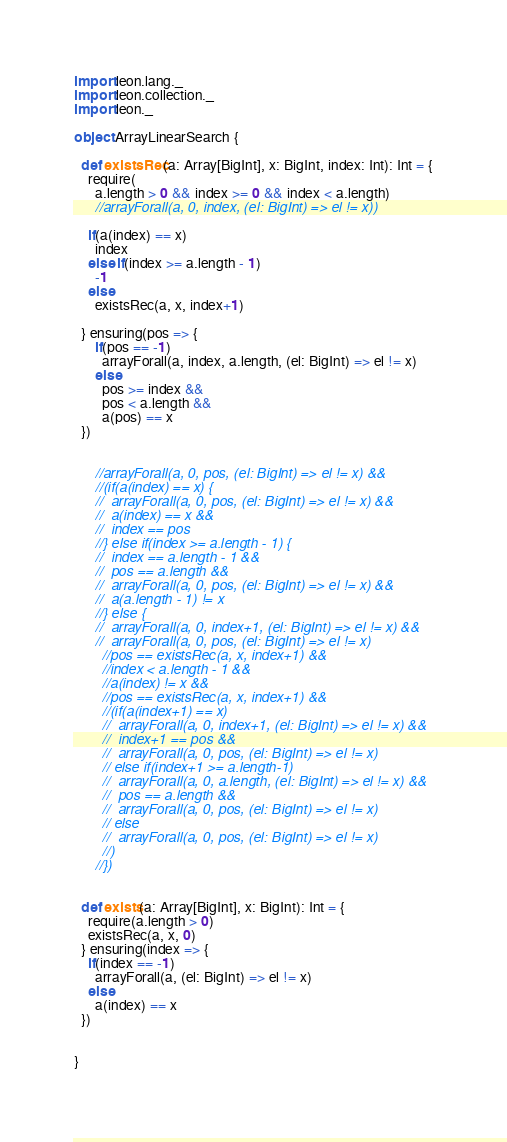Convert code to text. <code><loc_0><loc_0><loc_500><loc_500><_Scala_>import leon.lang._
import leon.collection._
import leon._

object ArrayLinearSearch {

  def existsRec(a: Array[BigInt], x: BigInt, index: Int): Int = {
    require(
      a.length > 0 && index >= 0 && index < a.length)
      //arrayForall(a, 0, index, (el: BigInt) => el != x))

    if(a(index) == x)
      index
    else if(index >= a.length - 1)
      -1
    else
      existsRec(a, x, index+1)
    
  } ensuring(pos => {
      if(pos == -1)
        arrayForall(a, index, a.length, (el: BigInt) => el != x)
      else
        pos >= index && 
        pos < a.length &&
        a(pos) == x
  })
        

      //arrayForall(a, 0, pos, (el: BigInt) => el != x) &&
      //(if(a(index) == x) {
      //  arrayForall(a, 0, pos, (el: BigInt) => el != x) &&
      //  a(index) == x &&
      //  index == pos
      //} else if(index >= a.length - 1) {
      //  index == a.length - 1 &&
      //  pos == a.length &&
      //  arrayForall(a, 0, pos, (el: BigInt) => el != x) &&
      //  a(a.length - 1) != x
      //} else {
      //  arrayForall(a, 0, index+1, (el: BigInt) => el != x) &&
      //  arrayForall(a, 0, pos, (el: BigInt) => el != x)
        //pos == existsRec(a, x, index+1) &&
        //index < a.length - 1 &&
        //a(index) != x &&
        //pos == existsRec(a, x, index+1) &&
        //(if(a(index+1) == x)
        //  arrayForall(a, 0, index+1, (el: BigInt) => el != x) &&
        //  index+1 == pos &&
        //  arrayForall(a, 0, pos, (el: BigInt) => el != x)
        // else if(index+1 >= a.length-1)
        //  arrayForall(a, 0, a.length, (el: BigInt) => el != x) &&
        //  pos == a.length &&
        //  arrayForall(a, 0, pos, (el: BigInt) => el != x)
        // else 
        //  arrayForall(a, 0, pos, (el: BigInt) => el != x)
        //)
      //})
      

  def exists(a: Array[BigInt], x: BigInt): Int = {
    require(a.length > 0)
    existsRec(a, x, 0)
  } ensuring(index => {
    if(index == -1)
      arrayForall(a, (el: BigInt) => el != x)
    else
      a(index) == x
  })


}
</code> 